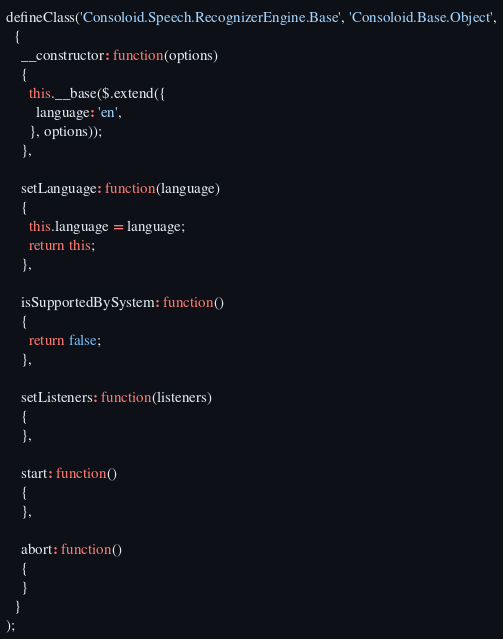Convert code to text. <code><loc_0><loc_0><loc_500><loc_500><_JavaScript_>defineClass('Consoloid.Speech.RecognizerEngine.Base', 'Consoloid.Base.Object',
  {
    __constructor: function(options)
    {
      this.__base($.extend({
        language: 'en',
      }, options));
    },

    setLanguage: function(language)
    {
      this.language = language;
      return this;
    },

    isSupportedBySystem: function()
    {
      return false;
    },

    setListeners: function(listeners)
    {
    },

    start: function()
    {
    },

    abort: function()
    {
    }
  }
);
</code> 